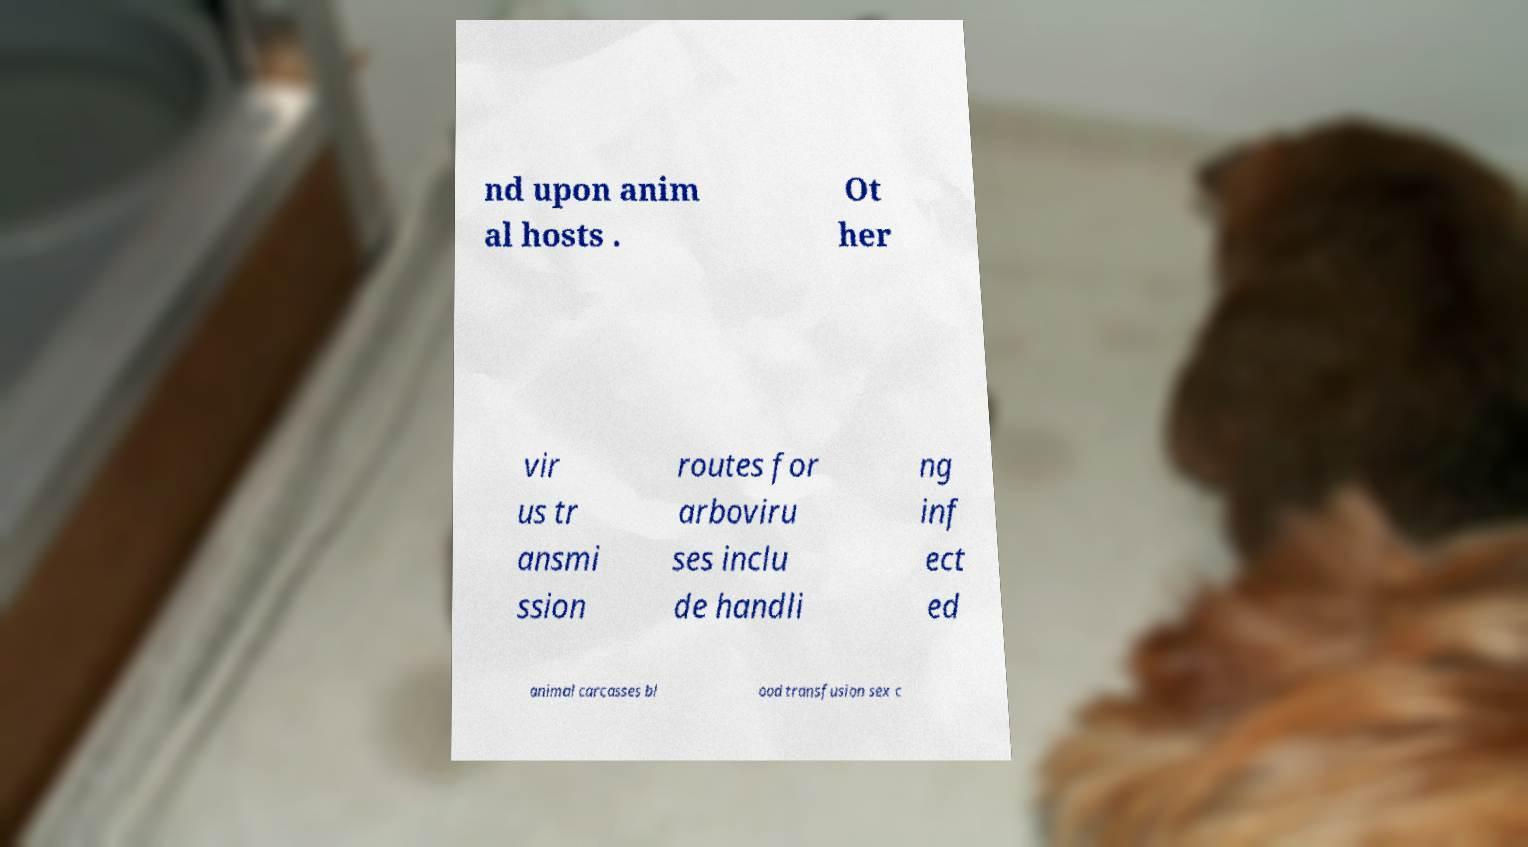What messages or text are displayed in this image? I need them in a readable, typed format. nd upon anim al hosts . Ot her vir us tr ansmi ssion routes for arboviru ses inclu de handli ng inf ect ed animal carcasses bl ood transfusion sex c 